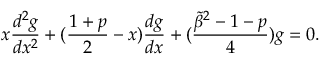<formula> <loc_0><loc_0><loc_500><loc_500>x { \frac { d ^ { 2 } g } { d x ^ { 2 } } } + ( { \frac { 1 + p } { 2 } } - x ) { \frac { d g } { d x } } + ( { \frac { { \tilde { \beta } } ^ { 2 } - 1 - p } { 4 } } ) g = 0 .</formula> 